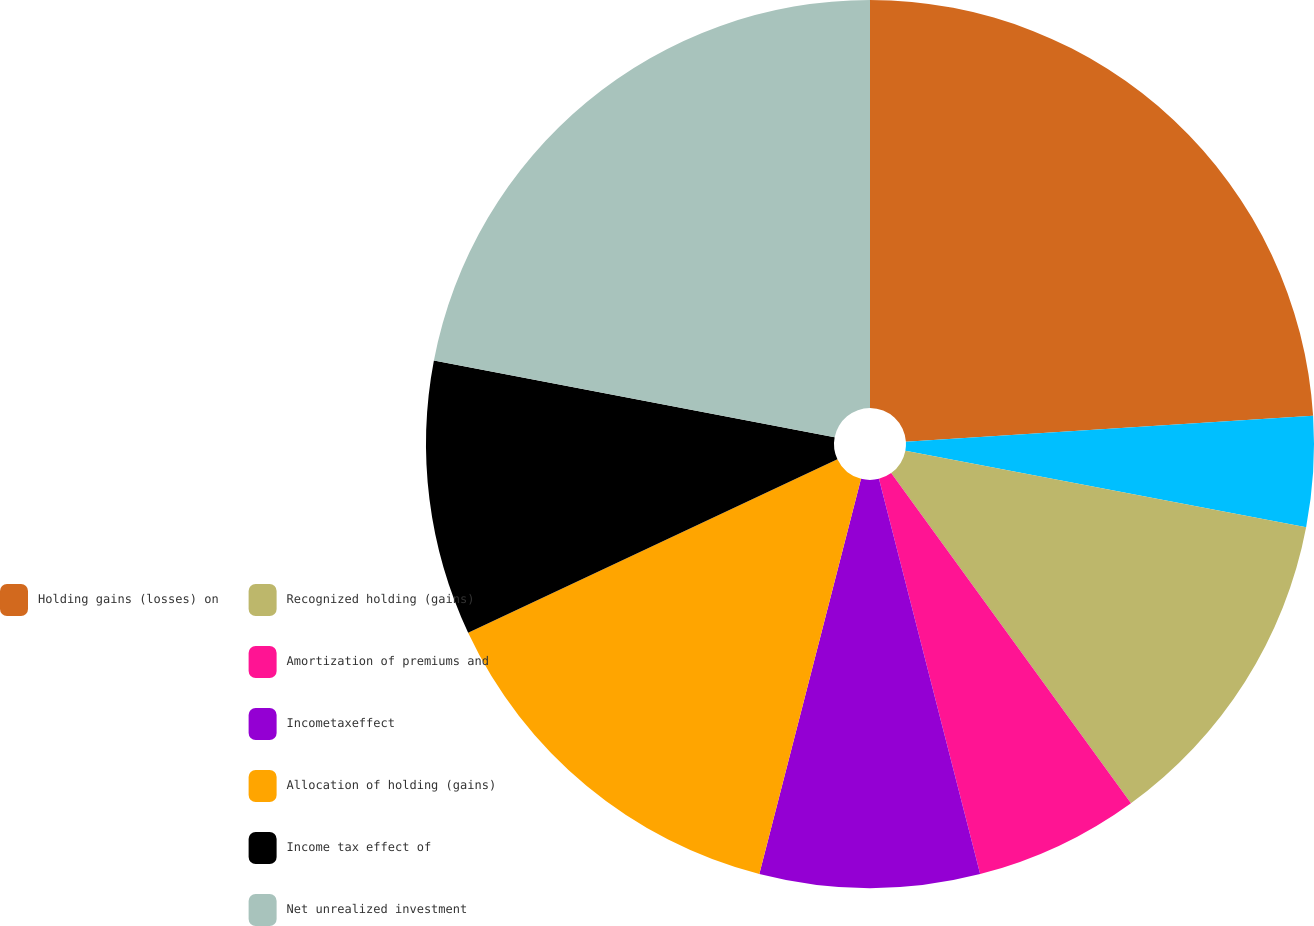Convert chart. <chart><loc_0><loc_0><loc_500><loc_500><pie_chart><fcel>Holding gains (losses) on<fcel>Unnamed: 1<fcel>Recognized holding (gains)<fcel>Amortization of premiums and<fcel>Incometaxeffect<fcel>Allocation of holding (gains)<fcel>Income tax effect of<fcel>Net unrealized investment<nl><fcel>23.99%<fcel>4.01%<fcel>12.0%<fcel>6.01%<fcel>8.0%<fcel>14.0%<fcel>10.0%<fcel>21.99%<nl></chart> 